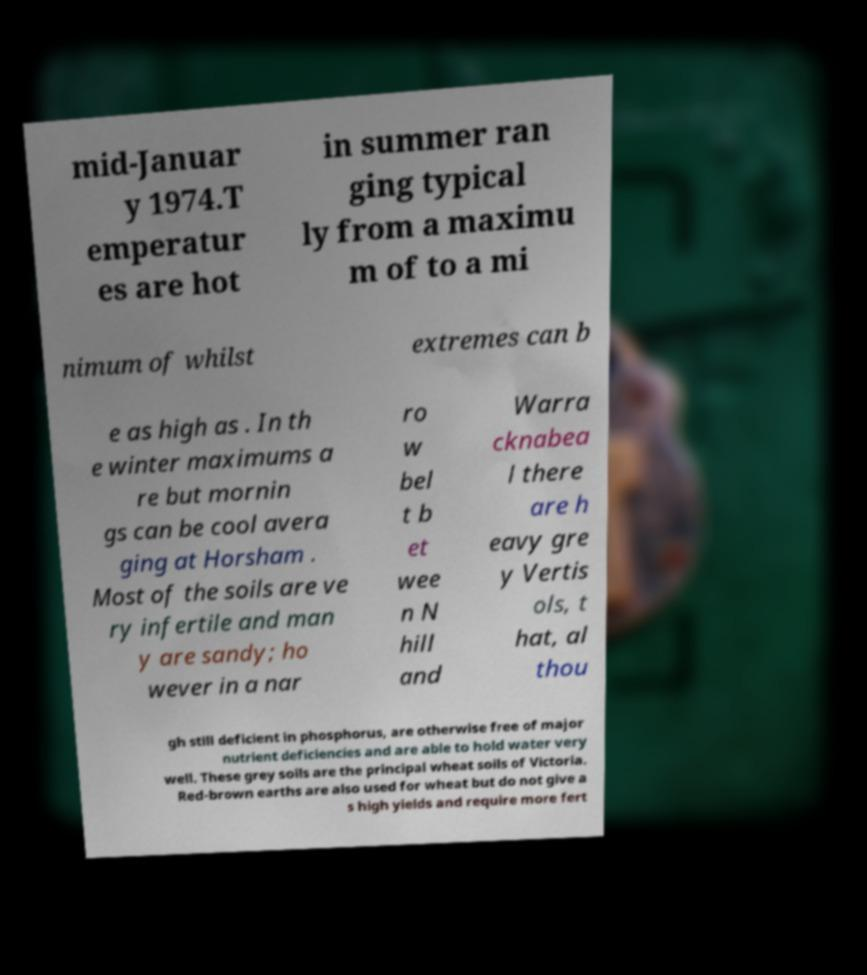For documentation purposes, I need the text within this image transcribed. Could you provide that? mid-Januar y 1974.T emperatur es are hot in summer ran ging typical ly from a maximu m of to a mi nimum of whilst extremes can b e as high as . In th e winter maximums a re but mornin gs can be cool avera ging at Horsham . Most of the soils are ve ry infertile and man y are sandy; ho wever in a nar ro w bel t b et wee n N hill and Warra cknabea l there are h eavy gre y Vertis ols, t hat, al thou gh still deficient in phosphorus, are otherwise free of major nutrient deficiencies and are able to hold water very well. These grey soils are the principal wheat soils of Victoria. Red-brown earths are also used for wheat but do not give a s high yields and require more fert 